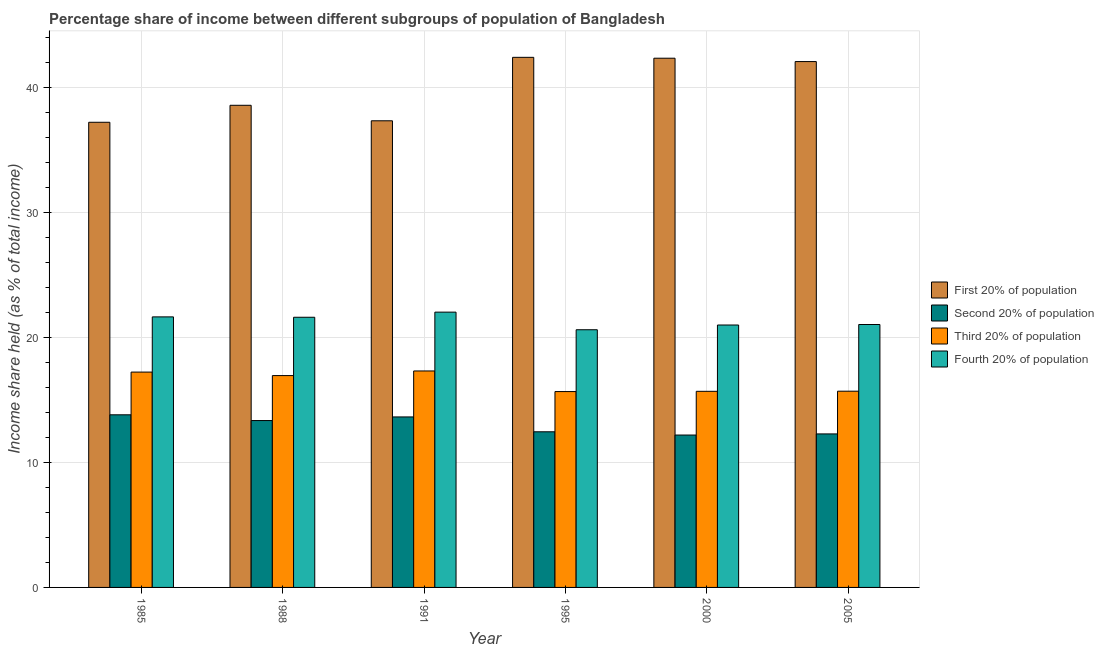Are the number of bars per tick equal to the number of legend labels?
Give a very brief answer. Yes. Are the number of bars on each tick of the X-axis equal?
Make the answer very short. Yes. What is the label of the 5th group of bars from the left?
Your response must be concise. 2000. What is the share of the income held by first 20% of the population in 2005?
Your response must be concise. 42.1. Across all years, what is the maximum share of the income held by first 20% of the population?
Ensure brevity in your answer.  42.44. Across all years, what is the minimum share of the income held by third 20% of the population?
Offer a very short reply. 15.68. What is the total share of the income held by first 20% of the population in the graph?
Your answer should be very brief. 240.11. What is the difference between the share of the income held by third 20% of the population in 1985 and that in 2005?
Keep it short and to the point. 1.53. What is the difference between the share of the income held by fourth 20% of the population in 2005 and the share of the income held by first 20% of the population in 2000?
Your answer should be very brief. 0.04. What is the average share of the income held by second 20% of the population per year?
Keep it short and to the point. 12.96. In the year 2000, what is the difference between the share of the income held by second 20% of the population and share of the income held by fourth 20% of the population?
Your response must be concise. 0. In how many years, is the share of the income held by fourth 20% of the population greater than 24 %?
Your answer should be very brief. 0. What is the ratio of the share of the income held by third 20% of the population in 1988 to that in 1991?
Provide a succinct answer. 0.98. Is the difference between the share of the income held by second 20% of the population in 1988 and 2000 greater than the difference between the share of the income held by third 20% of the population in 1988 and 2000?
Make the answer very short. No. What is the difference between the highest and the second highest share of the income held by first 20% of the population?
Make the answer very short. 0.07. What is the difference between the highest and the lowest share of the income held by fourth 20% of the population?
Your response must be concise. 1.41. What does the 3rd bar from the left in 2005 represents?
Your response must be concise. Third 20% of population. What does the 3rd bar from the right in 1988 represents?
Your answer should be compact. Second 20% of population. Is it the case that in every year, the sum of the share of the income held by first 20% of the population and share of the income held by second 20% of the population is greater than the share of the income held by third 20% of the population?
Your answer should be very brief. Yes. Are all the bars in the graph horizontal?
Keep it short and to the point. No. What is the difference between two consecutive major ticks on the Y-axis?
Provide a short and direct response. 10. Does the graph contain grids?
Keep it short and to the point. Yes. How many legend labels are there?
Provide a succinct answer. 4. What is the title of the graph?
Give a very brief answer. Percentage share of income between different subgroups of population of Bangladesh. Does "Argument" appear as one of the legend labels in the graph?
Offer a terse response. No. What is the label or title of the Y-axis?
Make the answer very short. Income share held (as % of total income). What is the Income share held (as % of total income) of First 20% of population in 1985?
Offer a terse response. 37.24. What is the Income share held (as % of total income) in Second 20% of population in 1985?
Provide a succinct answer. 13.82. What is the Income share held (as % of total income) of Third 20% of population in 1985?
Offer a very short reply. 17.24. What is the Income share held (as % of total income) of Fourth 20% of population in 1985?
Ensure brevity in your answer.  21.66. What is the Income share held (as % of total income) of First 20% of population in 1988?
Provide a short and direct response. 38.6. What is the Income share held (as % of total income) of Second 20% of population in 1988?
Your answer should be very brief. 13.36. What is the Income share held (as % of total income) in Third 20% of population in 1988?
Keep it short and to the point. 16.96. What is the Income share held (as % of total income) in Fourth 20% of population in 1988?
Your answer should be very brief. 21.63. What is the Income share held (as % of total income) in First 20% of population in 1991?
Make the answer very short. 37.36. What is the Income share held (as % of total income) of Second 20% of population in 1991?
Make the answer very short. 13.65. What is the Income share held (as % of total income) in Third 20% of population in 1991?
Keep it short and to the point. 17.33. What is the Income share held (as % of total income) of Fourth 20% of population in 1991?
Provide a succinct answer. 22.04. What is the Income share held (as % of total income) of First 20% of population in 1995?
Your answer should be very brief. 42.44. What is the Income share held (as % of total income) of Second 20% of population in 1995?
Your answer should be very brief. 12.46. What is the Income share held (as % of total income) of Third 20% of population in 1995?
Keep it short and to the point. 15.68. What is the Income share held (as % of total income) in Fourth 20% of population in 1995?
Make the answer very short. 20.63. What is the Income share held (as % of total income) in First 20% of population in 2000?
Provide a succinct answer. 42.37. What is the Income share held (as % of total income) of Third 20% of population in 2000?
Your response must be concise. 15.7. What is the Income share held (as % of total income) of Fourth 20% of population in 2000?
Your answer should be compact. 21.01. What is the Income share held (as % of total income) in First 20% of population in 2005?
Your response must be concise. 42.1. What is the Income share held (as % of total income) of Second 20% of population in 2005?
Offer a very short reply. 12.29. What is the Income share held (as % of total income) in Third 20% of population in 2005?
Provide a short and direct response. 15.71. What is the Income share held (as % of total income) in Fourth 20% of population in 2005?
Give a very brief answer. 21.05. Across all years, what is the maximum Income share held (as % of total income) of First 20% of population?
Your answer should be very brief. 42.44. Across all years, what is the maximum Income share held (as % of total income) in Second 20% of population?
Provide a short and direct response. 13.82. Across all years, what is the maximum Income share held (as % of total income) in Third 20% of population?
Ensure brevity in your answer.  17.33. Across all years, what is the maximum Income share held (as % of total income) in Fourth 20% of population?
Provide a short and direct response. 22.04. Across all years, what is the minimum Income share held (as % of total income) of First 20% of population?
Keep it short and to the point. 37.24. Across all years, what is the minimum Income share held (as % of total income) of Second 20% of population?
Make the answer very short. 12.2. Across all years, what is the minimum Income share held (as % of total income) of Third 20% of population?
Offer a terse response. 15.68. Across all years, what is the minimum Income share held (as % of total income) of Fourth 20% of population?
Keep it short and to the point. 20.63. What is the total Income share held (as % of total income) of First 20% of population in the graph?
Provide a succinct answer. 240.11. What is the total Income share held (as % of total income) of Second 20% of population in the graph?
Your answer should be very brief. 77.78. What is the total Income share held (as % of total income) in Third 20% of population in the graph?
Your answer should be very brief. 98.62. What is the total Income share held (as % of total income) of Fourth 20% of population in the graph?
Offer a terse response. 128.02. What is the difference between the Income share held (as % of total income) of First 20% of population in 1985 and that in 1988?
Offer a terse response. -1.36. What is the difference between the Income share held (as % of total income) of Second 20% of population in 1985 and that in 1988?
Ensure brevity in your answer.  0.46. What is the difference between the Income share held (as % of total income) of Third 20% of population in 1985 and that in 1988?
Your answer should be compact. 0.28. What is the difference between the Income share held (as % of total income) of Fourth 20% of population in 1985 and that in 1988?
Your answer should be compact. 0.03. What is the difference between the Income share held (as % of total income) in First 20% of population in 1985 and that in 1991?
Your response must be concise. -0.12. What is the difference between the Income share held (as % of total income) in Second 20% of population in 1985 and that in 1991?
Ensure brevity in your answer.  0.17. What is the difference between the Income share held (as % of total income) of Third 20% of population in 1985 and that in 1991?
Offer a terse response. -0.09. What is the difference between the Income share held (as % of total income) of Fourth 20% of population in 1985 and that in 1991?
Give a very brief answer. -0.38. What is the difference between the Income share held (as % of total income) in Second 20% of population in 1985 and that in 1995?
Your response must be concise. 1.36. What is the difference between the Income share held (as % of total income) in Third 20% of population in 1985 and that in 1995?
Your answer should be very brief. 1.56. What is the difference between the Income share held (as % of total income) in First 20% of population in 1985 and that in 2000?
Your answer should be compact. -5.13. What is the difference between the Income share held (as % of total income) in Second 20% of population in 1985 and that in 2000?
Give a very brief answer. 1.62. What is the difference between the Income share held (as % of total income) of Third 20% of population in 1985 and that in 2000?
Offer a very short reply. 1.54. What is the difference between the Income share held (as % of total income) in Fourth 20% of population in 1985 and that in 2000?
Offer a very short reply. 0.65. What is the difference between the Income share held (as % of total income) in First 20% of population in 1985 and that in 2005?
Keep it short and to the point. -4.86. What is the difference between the Income share held (as % of total income) of Second 20% of population in 1985 and that in 2005?
Your answer should be very brief. 1.53. What is the difference between the Income share held (as % of total income) in Third 20% of population in 1985 and that in 2005?
Make the answer very short. 1.53. What is the difference between the Income share held (as % of total income) in Fourth 20% of population in 1985 and that in 2005?
Your response must be concise. 0.61. What is the difference between the Income share held (as % of total income) of First 20% of population in 1988 and that in 1991?
Your answer should be compact. 1.24. What is the difference between the Income share held (as % of total income) in Second 20% of population in 1988 and that in 1991?
Your response must be concise. -0.29. What is the difference between the Income share held (as % of total income) in Third 20% of population in 1988 and that in 1991?
Offer a terse response. -0.37. What is the difference between the Income share held (as % of total income) in Fourth 20% of population in 1988 and that in 1991?
Offer a very short reply. -0.41. What is the difference between the Income share held (as % of total income) of First 20% of population in 1988 and that in 1995?
Ensure brevity in your answer.  -3.84. What is the difference between the Income share held (as % of total income) in Second 20% of population in 1988 and that in 1995?
Keep it short and to the point. 0.9. What is the difference between the Income share held (as % of total income) in Third 20% of population in 1988 and that in 1995?
Offer a terse response. 1.28. What is the difference between the Income share held (as % of total income) in First 20% of population in 1988 and that in 2000?
Make the answer very short. -3.77. What is the difference between the Income share held (as % of total income) of Second 20% of population in 1988 and that in 2000?
Your answer should be very brief. 1.16. What is the difference between the Income share held (as % of total income) in Third 20% of population in 1988 and that in 2000?
Keep it short and to the point. 1.26. What is the difference between the Income share held (as % of total income) of Fourth 20% of population in 1988 and that in 2000?
Keep it short and to the point. 0.62. What is the difference between the Income share held (as % of total income) in First 20% of population in 1988 and that in 2005?
Give a very brief answer. -3.5. What is the difference between the Income share held (as % of total income) of Second 20% of population in 1988 and that in 2005?
Your response must be concise. 1.07. What is the difference between the Income share held (as % of total income) in Third 20% of population in 1988 and that in 2005?
Provide a succinct answer. 1.25. What is the difference between the Income share held (as % of total income) in Fourth 20% of population in 1988 and that in 2005?
Provide a short and direct response. 0.58. What is the difference between the Income share held (as % of total income) in First 20% of population in 1991 and that in 1995?
Offer a very short reply. -5.08. What is the difference between the Income share held (as % of total income) in Second 20% of population in 1991 and that in 1995?
Make the answer very short. 1.19. What is the difference between the Income share held (as % of total income) in Third 20% of population in 1991 and that in 1995?
Give a very brief answer. 1.65. What is the difference between the Income share held (as % of total income) of Fourth 20% of population in 1991 and that in 1995?
Provide a short and direct response. 1.41. What is the difference between the Income share held (as % of total income) in First 20% of population in 1991 and that in 2000?
Your response must be concise. -5.01. What is the difference between the Income share held (as % of total income) in Second 20% of population in 1991 and that in 2000?
Your response must be concise. 1.45. What is the difference between the Income share held (as % of total income) in Third 20% of population in 1991 and that in 2000?
Offer a very short reply. 1.63. What is the difference between the Income share held (as % of total income) in First 20% of population in 1991 and that in 2005?
Provide a succinct answer. -4.74. What is the difference between the Income share held (as % of total income) of Second 20% of population in 1991 and that in 2005?
Keep it short and to the point. 1.36. What is the difference between the Income share held (as % of total income) of Third 20% of population in 1991 and that in 2005?
Provide a succinct answer. 1.62. What is the difference between the Income share held (as % of total income) of Fourth 20% of population in 1991 and that in 2005?
Your answer should be very brief. 0.99. What is the difference between the Income share held (as % of total income) of First 20% of population in 1995 and that in 2000?
Your answer should be very brief. 0.07. What is the difference between the Income share held (as % of total income) in Second 20% of population in 1995 and that in 2000?
Offer a very short reply. 0.26. What is the difference between the Income share held (as % of total income) of Third 20% of population in 1995 and that in 2000?
Your answer should be compact. -0.02. What is the difference between the Income share held (as % of total income) of Fourth 20% of population in 1995 and that in 2000?
Keep it short and to the point. -0.38. What is the difference between the Income share held (as % of total income) of First 20% of population in 1995 and that in 2005?
Keep it short and to the point. 0.34. What is the difference between the Income share held (as % of total income) in Second 20% of population in 1995 and that in 2005?
Offer a terse response. 0.17. What is the difference between the Income share held (as % of total income) of Third 20% of population in 1995 and that in 2005?
Your answer should be very brief. -0.03. What is the difference between the Income share held (as % of total income) of Fourth 20% of population in 1995 and that in 2005?
Your answer should be very brief. -0.42. What is the difference between the Income share held (as % of total income) of First 20% of population in 2000 and that in 2005?
Ensure brevity in your answer.  0.27. What is the difference between the Income share held (as % of total income) in Second 20% of population in 2000 and that in 2005?
Your response must be concise. -0.09. What is the difference between the Income share held (as % of total income) in Third 20% of population in 2000 and that in 2005?
Offer a terse response. -0.01. What is the difference between the Income share held (as % of total income) in Fourth 20% of population in 2000 and that in 2005?
Ensure brevity in your answer.  -0.04. What is the difference between the Income share held (as % of total income) in First 20% of population in 1985 and the Income share held (as % of total income) in Second 20% of population in 1988?
Your answer should be compact. 23.88. What is the difference between the Income share held (as % of total income) of First 20% of population in 1985 and the Income share held (as % of total income) of Third 20% of population in 1988?
Provide a succinct answer. 20.28. What is the difference between the Income share held (as % of total income) of First 20% of population in 1985 and the Income share held (as % of total income) of Fourth 20% of population in 1988?
Offer a very short reply. 15.61. What is the difference between the Income share held (as % of total income) in Second 20% of population in 1985 and the Income share held (as % of total income) in Third 20% of population in 1988?
Provide a short and direct response. -3.14. What is the difference between the Income share held (as % of total income) in Second 20% of population in 1985 and the Income share held (as % of total income) in Fourth 20% of population in 1988?
Keep it short and to the point. -7.81. What is the difference between the Income share held (as % of total income) in Third 20% of population in 1985 and the Income share held (as % of total income) in Fourth 20% of population in 1988?
Keep it short and to the point. -4.39. What is the difference between the Income share held (as % of total income) in First 20% of population in 1985 and the Income share held (as % of total income) in Second 20% of population in 1991?
Offer a terse response. 23.59. What is the difference between the Income share held (as % of total income) of First 20% of population in 1985 and the Income share held (as % of total income) of Third 20% of population in 1991?
Your answer should be very brief. 19.91. What is the difference between the Income share held (as % of total income) of Second 20% of population in 1985 and the Income share held (as % of total income) of Third 20% of population in 1991?
Give a very brief answer. -3.51. What is the difference between the Income share held (as % of total income) of Second 20% of population in 1985 and the Income share held (as % of total income) of Fourth 20% of population in 1991?
Your response must be concise. -8.22. What is the difference between the Income share held (as % of total income) of Third 20% of population in 1985 and the Income share held (as % of total income) of Fourth 20% of population in 1991?
Provide a short and direct response. -4.8. What is the difference between the Income share held (as % of total income) of First 20% of population in 1985 and the Income share held (as % of total income) of Second 20% of population in 1995?
Your answer should be compact. 24.78. What is the difference between the Income share held (as % of total income) in First 20% of population in 1985 and the Income share held (as % of total income) in Third 20% of population in 1995?
Give a very brief answer. 21.56. What is the difference between the Income share held (as % of total income) of First 20% of population in 1985 and the Income share held (as % of total income) of Fourth 20% of population in 1995?
Make the answer very short. 16.61. What is the difference between the Income share held (as % of total income) of Second 20% of population in 1985 and the Income share held (as % of total income) of Third 20% of population in 1995?
Make the answer very short. -1.86. What is the difference between the Income share held (as % of total income) of Second 20% of population in 1985 and the Income share held (as % of total income) of Fourth 20% of population in 1995?
Your answer should be compact. -6.81. What is the difference between the Income share held (as % of total income) in Third 20% of population in 1985 and the Income share held (as % of total income) in Fourth 20% of population in 1995?
Your answer should be very brief. -3.39. What is the difference between the Income share held (as % of total income) of First 20% of population in 1985 and the Income share held (as % of total income) of Second 20% of population in 2000?
Your answer should be compact. 25.04. What is the difference between the Income share held (as % of total income) of First 20% of population in 1985 and the Income share held (as % of total income) of Third 20% of population in 2000?
Offer a terse response. 21.54. What is the difference between the Income share held (as % of total income) in First 20% of population in 1985 and the Income share held (as % of total income) in Fourth 20% of population in 2000?
Offer a very short reply. 16.23. What is the difference between the Income share held (as % of total income) of Second 20% of population in 1985 and the Income share held (as % of total income) of Third 20% of population in 2000?
Offer a very short reply. -1.88. What is the difference between the Income share held (as % of total income) in Second 20% of population in 1985 and the Income share held (as % of total income) in Fourth 20% of population in 2000?
Ensure brevity in your answer.  -7.19. What is the difference between the Income share held (as % of total income) in Third 20% of population in 1985 and the Income share held (as % of total income) in Fourth 20% of population in 2000?
Your answer should be compact. -3.77. What is the difference between the Income share held (as % of total income) of First 20% of population in 1985 and the Income share held (as % of total income) of Second 20% of population in 2005?
Offer a very short reply. 24.95. What is the difference between the Income share held (as % of total income) of First 20% of population in 1985 and the Income share held (as % of total income) of Third 20% of population in 2005?
Offer a very short reply. 21.53. What is the difference between the Income share held (as % of total income) of First 20% of population in 1985 and the Income share held (as % of total income) of Fourth 20% of population in 2005?
Provide a short and direct response. 16.19. What is the difference between the Income share held (as % of total income) in Second 20% of population in 1985 and the Income share held (as % of total income) in Third 20% of population in 2005?
Make the answer very short. -1.89. What is the difference between the Income share held (as % of total income) of Second 20% of population in 1985 and the Income share held (as % of total income) of Fourth 20% of population in 2005?
Provide a succinct answer. -7.23. What is the difference between the Income share held (as % of total income) in Third 20% of population in 1985 and the Income share held (as % of total income) in Fourth 20% of population in 2005?
Offer a very short reply. -3.81. What is the difference between the Income share held (as % of total income) in First 20% of population in 1988 and the Income share held (as % of total income) in Second 20% of population in 1991?
Make the answer very short. 24.95. What is the difference between the Income share held (as % of total income) in First 20% of population in 1988 and the Income share held (as % of total income) in Third 20% of population in 1991?
Keep it short and to the point. 21.27. What is the difference between the Income share held (as % of total income) of First 20% of population in 1988 and the Income share held (as % of total income) of Fourth 20% of population in 1991?
Offer a terse response. 16.56. What is the difference between the Income share held (as % of total income) of Second 20% of population in 1988 and the Income share held (as % of total income) of Third 20% of population in 1991?
Provide a short and direct response. -3.97. What is the difference between the Income share held (as % of total income) of Second 20% of population in 1988 and the Income share held (as % of total income) of Fourth 20% of population in 1991?
Your response must be concise. -8.68. What is the difference between the Income share held (as % of total income) of Third 20% of population in 1988 and the Income share held (as % of total income) of Fourth 20% of population in 1991?
Make the answer very short. -5.08. What is the difference between the Income share held (as % of total income) of First 20% of population in 1988 and the Income share held (as % of total income) of Second 20% of population in 1995?
Make the answer very short. 26.14. What is the difference between the Income share held (as % of total income) in First 20% of population in 1988 and the Income share held (as % of total income) in Third 20% of population in 1995?
Your response must be concise. 22.92. What is the difference between the Income share held (as % of total income) in First 20% of population in 1988 and the Income share held (as % of total income) in Fourth 20% of population in 1995?
Offer a terse response. 17.97. What is the difference between the Income share held (as % of total income) in Second 20% of population in 1988 and the Income share held (as % of total income) in Third 20% of population in 1995?
Give a very brief answer. -2.32. What is the difference between the Income share held (as % of total income) of Second 20% of population in 1988 and the Income share held (as % of total income) of Fourth 20% of population in 1995?
Make the answer very short. -7.27. What is the difference between the Income share held (as % of total income) of Third 20% of population in 1988 and the Income share held (as % of total income) of Fourth 20% of population in 1995?
Offer a terse response. -3.67. What is the difference between the Income share held (as % of total income) in First 20% of population in 1988 and the Income share held (as % of total income) in Second 20% of population in 2000?
Provide a succinct answer. 26.4. What is the difference between the Income share held (as % of total income) of First 20% of population in 1988 and the Income share held (as % of total income) of Third 20% of population in 2000?
Make the answer very short. 22.9. What is the difference between the Income share held (as % of total income) in First 20% of population in 1988 and the Income share held (as % of total income) in Fourth 20% of population in 2000?
Offer a terse response. 17.59. What is the difference between the Income share held (as % of total income) of Second 20% of population in 1988 and the Income share held (as % of total income) of Third 20% of population in 2000?
Ensure brevity in your answer.  -2.34. What is the difference between the Income share held (as % of total income) in Second 20% of population in 1988 and the Income share held (as % of total income) in Fourth 20% of population in 2000?
Provide a succinct answer. -7.65. What is the difference between the Income share held (as % of total income) in Third 20% of population in 1988 and the Income share held (as % of total income) in Fourth 20% of population in 2000?
Ensure brevity in your answer.  -4.05. What is the difference between the Income share held (as % of total income) of First 20% of population in 1988 and the Income share held (as % of total income) of Second 20% of population in 2005?
Your answer should be compact. 26.31. What is the difference between the Income share held (as % of total income) of First 20% of population in 1988 and the Income share held (as % of total income) of Third 20% of population in 2005?
Offer a terse response. 22.89. What is the difference between the Income share held (as % of total income) in First 20% of population in 1988 and the Income share held (as % of total income) in Fourth 20% of population in 2005?
Keep it short and to the point. 17.55. What is the difference between the Income share held (as % of total income) of Second 20% of population in 1988 and the Income share held (as % of total income) of Third 20% of population in 2005?
Provide a short and direct response. -2.35. What is the difference between the Income share held (as % of total income) in Second 20% of population in 1988 and the Income share held (as % of total income) in Fourth 20% of population in 2005?
Your answer should be compact. -7.69. What is the difference between the Income share held (as % of total income) in Third 20% of population in 1988 and the Income share held (as % of total income) in Fourth 20% of population in 2005?
Provide a succinct answer. -4.09. What is the difference between the Income share held (as % of total income) in First 20% of population in 1991 and the Income share held (as % of total income) in Second 20% of population in 1995?
Provide a succinct answer. 24.9. What is the difference between the Income share held (as % of total income) of First 20% of population in 1991 and the Income share held (as % of total income) of Third 20% of population in 1995?
Your answer should be very brief. 21.68. What is the difference between the Income share held (as % of total income) in First 20% of population in 1991 and the Income share held (as % of total income) in Fourth 20% of population in 1995?
Your response must be concise. 16.73. What is the difference between the Income share held (as % of total income) in Second 20% of population in 1991 and the Income share held (as % of total income) in Third 20% of population in 1995?
Ensure brevity in your answer.  -2.03. What is the difference between the Income share held (as % of total income) in Second 20% of population in 1991 and the Income share held (as % of total income) in Fourth 20% of population in 1995?
Your answer should be very brief. -6.98. What is the difference between the Income share held (as % of total income) in First 20% of population in 1991 and the Income share held (as % of total income) in Second 20% of population in 2000?
Your answer should be compact. 25.16. What is the difference between the Income share held (as % of total income) of First 20% of population in 1991 and the Income share held (as % of total income) of Third 20% of population in 2000?
Your answer should be very brief. 21.66. What is the difference between the Income share held (as % of total income) in First 20% of population in 1991 and the Income share held (as % of total income) in Fourth 20% of population in 2000?
Provide a succinct answer. 16.35. What is the difference between the Income share held (as % of total income) in Second 20% of population in 1991 and the Income share held (as % of total income) in Third 20% of population in 2000?
Make the answer very short. -2.05. What is the difference between the Income share held (as % of total income) in Second 20% of population in 1991 and the Income share held (as % of total income) in Fourth 20% of population in 2000?
Your answer should be compact. -7.36. What is the difference between the Income share held (as % of total income) in Third 20% of population in 1991 and the Income share held (as % of total income) in Fourth 20% of population in 2000?
Your answer should be compact. -3.68. What is the difference between the Income share held (as % of total income) of First 20% of population in 1991 and the Income share held (as % of total income) of Second 20% of population in 2005?
Offer a very short reply. 25.07. What is the difference between the Income share held (as % of total income) in First 20% of population in 1991 and the Income share held (as % of total income) in Third 20% of population in 2005?
Provide a succinct answer. 21.65. What is the difference between the Income share held (as % of total income) of First 20% of population in 1991 and the Income share held (as % of total income) of Fourth 20% of population in 2005?
Your answer should be very brief. 16.31. What is the difference between the Income share held (as % of total income) of Second 20% of population in 1991 and the Income share held (as % of total income) of Third 20% of population in 2005?
Your answer should be compact. -2.06. What is the difference between the Income share held (as % of total income) in Second 20% of population in 1991 and the Income share held (as % of total income) in Fourth 20% of population in 2005?
Keep it short and to the point. -7.4. What is the difference between the Income share held (as % of total income) in Third 20% of population in 1991 and the Income share held (as % of total income) in Fourth 20% of population in 2005?
Your response must be concise. -3.72. What is the difference between the Income share held (as % of total income) of First 20% of population in 1995 and the Income share held (as % of total income) of Second 20% of population in 2000?
Your answer should be very brief. 30.24. What is the difference between the Income share held (as % of total income) of First 20% of population in 1995 and the Income share held (as % of total income) of Third 20% of population in 2000?
Provide a short and direct response. 26.74. What is the difference between the Income share held (as % of total income) of First 20% of population in 1995 and the Income share held (as % of total income) of Fourth 20% of population in 2000?
Make the answer very short. 21.43. What is the difference between the Income share held (as % of total income) of Second 20% of population in 1995 and the Income share held (as % of total income) of Third 20% of population in 2000?
Provide a short and direct response. -3.24. What is the difference between the Income share held (as % of total income) in Second 20% of population in 1995 and the Income share held (as % of total income) in Fourth 20% of population in 2000?
Provide a succinct answer. -8.55. What is the difference between the Income share held (as % of total income) in Third 20% of population in 1995 and the Income share held (as % of total income) in Fourth 20% of population in 2000?
Your answer should be compact. -5.33. What is the difference between the Income share held (as % of total income) in First 20% of population in 1995 and the Income share held (as % of total income) in Second 20% of population in 2005?
Give a very brief answer. 30.15. What is the difference between the Income share held (as % of total income) of First 20% of population in 1995 and the Income share held (as % of total income) of Third 20% of population in 2005?
Offer a very short reply. 26.73. What is the difference between the Income share held (as % of total income) of First 20% of population in 1995 and the Income share held (as % of total income) of Fourth 20% of population in 2005?
Provide a short and direct response. 21.39. What is the difference between the Income share held (as % of total income) in Second 20% of population in 1995 and the Income share held (as % of total income) in Third 20% of population in 2005?
Offer a very short reply. -3.25. What is the difference between the Income share held (as % of total income) in Second 20% of population in 1995 and the Income share held (as % of total income) in Fourth 20% of population in 2005?
Keep it short and to the point. -8.59. What is the difference between the Income share held (as % of total income) of Third 20% of population in 1995 and the Income share held (as % of total income) of Fourth 20% of population in 2005?
Your answer should be compact. -5.37. What is the difference between the Income share held (as % of total income) of First 20% of population in 2000 and the Income share held (as % of total income) of Second 20% of population in 2005?
Give a very brief answer. 30.08. What is the difference between the Income share held (as % of total income) of First 20% of population in 2000 and the Income share held (as % of total income) of Third 20% of population in 2005?
Offer a very short reply. 26.66. What is the difference between the Income share held (as % of total income) of First 20% of population in 2000 and the Income share held (as % of total income) of Fourth 20% of population in 2005?
Your answer should be compact. 21.32. What is the difference between the Income share held (as % of total income) of Second 20% of population in 2000 and the Income share held (as % of total income) of Third 20% of population in 2005?
Your answer should be very brief. -3.51. What is the difference between the Income share held (as % of total income) of Second 20% of population in 2000 and the Income share held (as % of total income) of Fourth 20% of population in 2005?
Ensure brevity in your answer.  -8.85. What is the difference between the Income share held (as % of total income) of Third 20% of population in 2000 and the Income share held (as % of total income) of Fourth 20% of population in 2005?
Your answer should be compact. -5.35. What is the average Income share held (as % of total income) of First 20% of population per year?
Give a very brief answer. 40.02. What is the average Income share held (as % of total income) in Second 20% of population per year?
Ensure brevity in your answer.  12.96. What is the average Income share held (as % of total income) of Third 20% of population per year?
Your answer should be compact. 16.44. What is the average Income share held (as % of total income) in Fourth 20% of population per year?
Offer a very short reply. 21.34. In the year 1985, what is the difference between the Income share held (as % of total income) in First 20% of population and Income share held (as % of total income) in Second 20% of population?
Make the answer very short. 23.42. In the year 1985, what is the difference between the Income share held (as % of total income) in First 20% of population and Income share held (as % of total income) in Fourth 20% of population?
Ensure brevity in your answer.  15.58. In the year 1985, what is the difference between the Income share held (as % of total income) in Second 20% of population and Income share held (as % of total income) in Third 20% of population?
Ensure brevity in your answer.  -3.42. In the year 1985, what is the difference between the Income share held (as % of total income) in Second 20% of population and Income share held (as % of total income) in Fourth 20% of population?
Keep it short and to the point. -7.84. In the year 1985, what is the difference between the Income share held (as % of total income) of Third 20% of population and Income share held (as % of total income) of Fourth 20% of population?
Your answer should be compact. -4.42. In the year 1988, what is the difference between the Income share held (as % of total income) of First 20% of population and Income share held (as % of total income) of Second 20% of population?
Your answer should be compact. 25.24. In the year 1988, what is the difference between the Income share held (as % of total income) in First 20% of population and Income share held (as % of total income) in Third 20% of population?
Make the answer very short. 21.64. In the year 1988, what is the difference between the Income share held (as % of total income) in First 20% of population and Income share held (as % of total income) in Fourth 20% of population?
Offer a terse response. 16.97. In the year 1988, what is the difference between the Income share held (as % of total income) in Second 20% of population and Income share held (as % of total income) in Fourth 20% of population?
Provide a succinct answer. -8.27. In the year 1988, what is the difference between the Income share held (as % of total income) of Third 20% of population and Income share held (as % of total income) of Fourth 20% of population?
Make the answer very short. -4.67. In the year 1991, what is the difference between the Income share held (as % of total income) of First 20% of population and Income share held (as % of total income) of Second 20% of population?
Provide a short and direct response. 23.71. In the year 1991, what is the difference between the Income share held (as % of total income) in First 20% of population and Income share held (as % of total income) in Third 20% of population?
Provide a short and direct response. 20.03. In the year 1991, what is the difference between the Income share held (as % of total income) of First 20% of population and Income share held (as % of total income) of Fourth 20% of population?
Offer a very short reply. 15.32. In the year 1991, what is the difference between the Income share held (as % of total income) of Second 20% of population and Income share held (as % of total income) of Third 20% of population?
Provide a short and direct response. -3.68. In the year 1991, what is the difference between the Income share held (as % of total income) of Second 20% of population and Income share held (as % of total income) of Fourth 20% of population?
Ensure brevity in your answer.  -8.39. In the year 1991, what is the difference between the Income share held (as % of total income) in Third 20% of population and Income share held (as % of total income) in Fourth 20% of population?
Your answer should be compact. -4.71. In the year 1995, what is the difference between the Income share held (as % of total income) of First 20% of population and Income share held (as % of total income) of Second 20% of population?
Offer a terse response. 29.98. In the year 1995, what is the difference between the Income share held (as % of total income) in First 20% of population and Income share held (as % of total income) in Third 20% of population?
Your answer should be compact. 26.76. In the year 1995, what is the difference between the Income share held (as % of total income) in First 20% of population and Income share held (as % of total income) in Fourth 20% of population?
Your response must be concise. 21.81. In the year 1995, what is the difference between the Income share held (as % of total income) in Second 20% of population and Income share held (as % of total income) in Third 20% of population?
Your answer should be compact. -3.22. In the year 1995, what is the difference between the Income share held (as % of total income) of Second 20% of population and Income share held (as % of total income) of Fourth 20% of population?
Offer a terse response. -8.17. In the year 1995, what is the difference between the Income share held (as % of total income) of Third 20% of population and Income share held (as % of total income) of Fourth 20% of population?
Provide a short and direct response. -4.95. In the year 2000, what is the difference between the Income share held (as % of total income) in First 20% of population and Income share held (as % of total income) in Second 20% of population?
Your answer should be very brief. 30.17. In the year 2000, what is the difference between the Income share held (as % of total income) in First 20% of population and Income share held (as % of total income) in Third 20% of population?
Your answer should be very brief. 26.67. In the year 2000, what is the difference between the Income share held (as % of total income) in First 20% of population and Income share held (as % of total income) in Fourth 20% of population?
Keep it short and to the point. 21.36. In the year 2000, what is the difference between the Income share held (as % of total income) in Second 20% of population and Income share held (as % of total income) in Fourth 20% of population?
Offer a terse response. -8.81. In the year 2000, what is the difference between the Income share held (as % of total income) of Third 20% of population and Income share held (as % of total income) of Fourth 20% of population?
Offer a terse response. -5.31. In the year 2005, what is the difference between the Income share held (as % of total income) in First 20% of population and Income share held (as % of total income) in Second 20% of population?
Your answer should be very brief. 29.81. In the year 2005, what is the difference between the Income share held (as % of total income) in First 20% of population and Income share held (as % of total income) in Third 20% of population?
Give a very brief answer. 26.39. In the year 2005, what is the difference between the Income share held (as % of total income) of First 20% of population and Income share held (as % of total income) of Fourth 20% of population?
Provide a short and direct response. 21.05. In the year 2005, what is the difference between the Income share held (as % of total income) of Second 20% of population and Income share held (as % of total income) of Third 20% of population?
Keep it short and to the point. -3.42. In the year 2005, what is the difference between the Income share held (as % of total income) of Second 20% of population and Income share held (as % of total income) of Fourth 20% of population?
Offer a terse response. -8.76. In the year 2005, what is the difference between the Income share held (as % of total income) of Third 20% of population and Income share held (as % of total income) of Fourth 20% of population?
Offer a terse response. -5.34. What is the ratio of the Income share held (as % of total income) in First 20% of population in 1985 to that in 1988?
Provide a short and direct response. 0.96. What is the ratio of the Income share held (as % of total income) of Second 20% of population in 1985 to that in 1988?
Keep it short and to the point. 1.03. What is the ratio of the Income share held (as % of total income) in Third 20% of population in 1985 to that in 1988?
Ensure brevity in your answer.  1.02. What is the ratio of the Income share held (as % of total income) of Fourth 20% of population in 1985 to that in 1988?
Give a very brief answer. 1. What is the ratio of the Income share held (as % of total income) of First 20% of population in 1985 to that in 1991?
Ensure brevity in your answer.  1. What is the ratio of the Income share held (as % of total income) of Second 20% of population in 1985 to that in 1991?
Give a very brief answer. 1.01. What is the ratio of the Income share held (as % of total income) in Fourth 20% of population in 1985 to that in 1991?
Give a very brief answer. 0.98. What is the ratio of the Income share held (as % of total income) in First 20% of population in 1985 to that in 1995?
Your response must be concise. 0.88. What is the ratio of the Income share held (as % of total income) in Second 20% of population in 1985 to that in 1995?
Keep it short and to the point. 1.11. What is the ratio of the Income share held (as % of total income) of Third 20% of population in 1985 to that in 1995?
Offer a very short reply. 1.1. What is the ratio of the Income share held (as % of total income) in Fourth 20% of population in 1985 to that in 1995?
Make the answer very short. 1.05. What is the ratio of the Income share held (as % of total income) in First 20% of population in 1985 to that in 2000?
Keep it short and to the point. 0.88. What is the ratio of the Income share held (as % of total income) of Second 20% of population in 1985 to that in 2000?
Your response must be concise. 1.13. What is the ratio of the Income share held (as % of total income) in Third 20% of population in 1985 to that in 2000?
Ensure brevity in your answer.  1.1. What is the ratio of the Income share held (as % of total income) in Fourth 20% of population in 1985 to that in 2000?
Your response must be concise. 1.03. What is the ratio of the Income share held (as % of total income) of First 20% of population in 1985 to that in 2005?
Ensure brevity in your answer.  0.88. What is the ratio of the Income share held (as % of total income) in Second 20% of population in 1985 to that in 2005?
Make the answer very short. 1.12. What is the ratio of the Income share held (as % of total income) in Third 20% of population in 1985 to that in 2005?
Provide a succinct answer. 1.1. What is the ratio of the Income share held (as % of total income) of Fourth 20% of population in 1985 to that in 2005?
Keep it short and to the point. 1.03. What is the ratio of the Income share held (as % of total income) of First 20% of population in 1988 to that in 1991?
Your answer should be very brief. 1.03. What is the ratio of the Income share held (as % of total income) of Second 20% of population in 1988 to that in 1991?
Offer a terse response. 0.98. What is the ratio of the Income share held (as % of total income) of Third 20% of population in 1988 to that in 1991?
Your response must be concise. 0.98. What is the ratio of the Income share held (as % of total income) of Fourth 20% of population in 1988 to that in 1991?
Your response must be concise. 0.98. What is the ratio of the Income share held (as % of total income) of First 20% of population in 1988 to that in 1995?
Your answer should be compact. 0.91. What is the ratio of the Income share held (as % of total income) of Second 20% of population in 1988 to that in 1995?
Provide a succinct answer. 1.07. What is the ratio of the Income share held (as % of total income) in Third 20% of population in 1988 to that in 1995?
Your answer should be compact. 1.08. What is the ratio of the Income share held (as % of total income) in Fourth 20% of population in 1988 to that in 1995?
Keep it short and to the point. 1.05. What is the ratio of the Income share held (as % of total income) of First 20% of population in 1988 to that in 2000?
Your response must be concise. 0.91. What is the ratio of the Income share held (as % of total income) of Second 20% of population in 1988 to that in 2000?
Provide a short and direct response. 1.1. What is the ratio of the Income share held (as % of total income) in Third 20% of population in 1988 to that in 2000?
Your response must be concise. 1.08. What is the ratio of the Income share held (as % of total income) of Fourth 20% of population in 1988 to that in 2000?
Provide a succinct answer. 1.03. What is the ratio of the Income share held (as % of total income) in First 20% of population in 1988 to that in 2005?
Provide a succinct answer. 0.92. What is the ratio of the Income share held (as % of total income) in Second 20% of population in 1988 to that in 2005?
Ensure brevity in your answer.  1.09. What is the ratio of the Income share held (as % of total income) in Third 20% of population in 1988 to that in 2005?
Offer a very short reply. 1.08. What is the ratio of the Income share held (as % of total income) of Fourth 20% of population in 1988 to that in 2005?
Provide a succinct answer. 1.03. What is the ratio of the Income share held (as % of total income) in First 20% of population in 1991 to that in 1995?
Ensure brevity in your answer.  0.88. What is the ratio of the Income share held (as % of total income) in Second 20% of population in 1991 to that in 1995?
Give a very brief answer. 1.1. What is the ratio of the Income share held (as % of total income) of Third 20% of population in 1991 to that in 1995?
Your answer should be compact. 1.11. What is the ratio of the Income share held (as % of total income) in Fourth 20% of population in 1991 to that in 1995?
Offer a very short reply. 1.07. What is the ratio of the Income share held (as % of total income) in First 20% of population in 1991 to that in 2000?
Ensure brevity in your answer.  0.88. What is the ratio of the Income share held (as % of total income) of Second 20% of population in 1991 to that in 2000?
Your answer should be very brief. 1.12. What is the ratio of the Income share held (as % of total income) of Third 20% of population in 1991 to that in 2000?
Provide a succinct answer. 1.1. What is the ratio of the Income share held (as % of total income) of Fourth 20% of population in 1991 to that in 2000?
Provide a short and direct response. 1.05. What is the ratio of the Income share held (as % of total income) in First 20% of population in 1991 to that in 2005?
Make the answer very short. 0.89. What is the ratio of the Income share held (as % of total income) of Second 20% of population in 1991 to that in 2005?
Provide a short and direct response. 1.11. What is the ratio of the Income share held (as % of total income) of Third 20% of population in 1991 to that in 2005?
Provide a succinct answer. 1.1. What is the ratio of the Income share held (as % of total income) in Fourth 20% of population in 1991 to that in 2005?
Make the answer very short. 1.05. What is the ratio of the Income share held (as % of total income) of Second 20% of population in 1995 to that in 2000?
Offer a very short reply. 1.02. What is the ratio of the Income share held (as % of total income) in Fourth 20% of population in 1995 to that in 2000?
Your answer should be very brief. 0.98. What is the ratio of the Income share held (as % of total income) of Second 20% of population in 1995 to that in 2005?
Your response must be concise. 1.01. What is the ratio of the Income share held (as % of total income) in First 20% of population in 2000 to that in 2005?
Offer a very short reply. 1.01. What is the ratio of the Income share held (as % of total income) of Second 20% of population in 2000 to that in 2005?
Offer a terse response. 0.99. What is the difference between the highest and the second highest Income share held (as % of total income) in First 20% of population?
Provide a short and direct response. 0.07. What is the difference between the highest and the second highest Income share held (as % of total income) of Second 20% of population?
Ensure brevity in your answer.  0.17. What is the difference between the highest and the second highest Income share held (as % of total income) of Third 20% of population?
Ensure brevity in your answer.  0.09. What is the difference between the highest and the second highest Income share held (as % of total income) in Fourth 20% of population?
Provide a short and direct response. 0.38. What is the difference between the highest and the lowest Income share held (as % of total income) in Second 20% of population?
Offer a terse response. 1.62. What is the difference between the highest and the lowest Income share held (as % of total income) in Third 20% of population?
Your response must be concise. 1.65. What is the difference between the highest and the lowest Income share held (as % of total income) of Fourth 20% of population?
Ensure brevity in your answer.  1.41. 